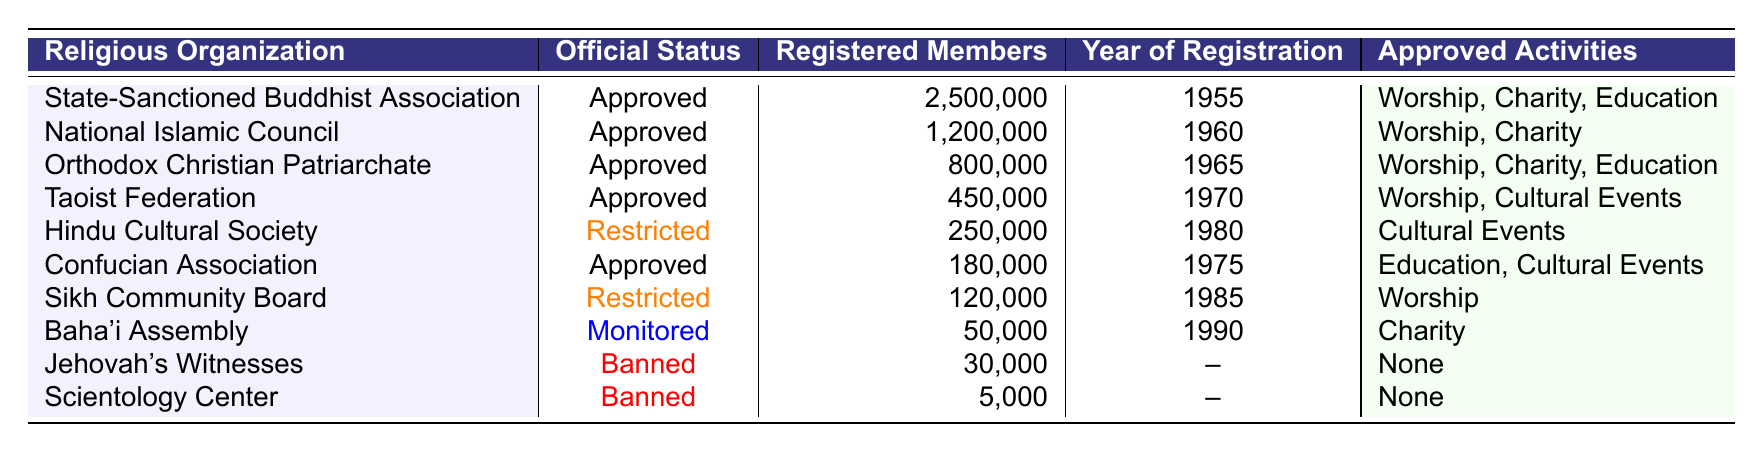What is the total number of registered members in approved religious organizations? To find the total, I will sum the registered members of all organizations with "Approved" status. The organizations with approved status and their members are: State-Sanctioned Buddhist Association (2,500,000), National Islamic Council (1,200,000), Orthodox Christian Patriarchate (800,000), Taoist Federation (450,000), and Confucian Association (180,000). Adding these values gives: 2,500,000 + 1,200,000 + 800,000 + 450,000 + 180,000 = 5,130,000.
Answer: 5,130,000 What is the year of registration for the Sikh Community Board? The table lists the year of registration for the Sikh Community Board as 1985.
Answer: 1985 Which religious organization has the least number of registered members? By examining the registered members' figures in the table, the Jehovah's Witnesses with 30,000 registered members have the least.
Answer: Jehovah's Witnesses Is the Hindu Cultural Society approved? The status of the Hindu Cultural Society is marked as "Restricted" in the table.
Answer: No How many religious organizations have registered members over 1,000,000? I will check the registered members for each organization. The organizations with over 1,000,000 members are the State-Sanctioned Buddhist Association (2,500,000) and the National Islamic Council (1,200,000). There are 2 such organizations.
Answer: 2 What percentage of the total registered members are from the State-Sanctioned Buddhist Association? First, I need to calculate the total registered members: 5,130,000 (as found previously). The registered members of the State-Sanctioned Buddhist Association are 2,500,000. The percentage is (2,500,000 / 5,130,000) * 100 = 48.74%.
Answer: 48.74% Which approved organization has the highest number of registered members? I will compare registered members among approved organizations. The State-Sanctioned Buddhist Association has 2,500,000 members, followed by the National Islamic Council with 1,200,000. So, the highest is from the State-Sanctioned Buddhist Association.
Answer: State-Sanctioned Buddhist Association What activities are approved for the Baha'i Assembly? According to the table, the approved activities for the Baha'i Assembly include "Charity."
Answer: Charity How many organizations are banned? The table lists two banned organizations: Jehovah's Witnesses and Scientology Center, making a total of 2.
Answer: 2 What is the difference in registered members between the Orthodox Christian Patriarchate and the Taoist Federation? The Orthodox Christian Patriarchate has 800,000 members and the Taoist Federation has 450,000. The difference is 800,000 - 450,000 = 350,000.
Answer: 350,000 